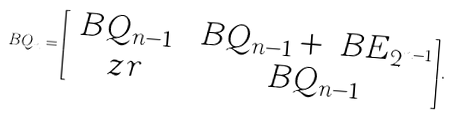<formula> <loc_0><loc_0><loc_500><loc_500>\ B Q _ { n } = \begin{bmatrix} \ B Q _ { n - 1 } & \ B Q _ { n - 1 } + \ B E _ { 2 ^ { n - 1 } } \\ \ z r & \ B Q _ { n - 1 } \end{bmatrix} .</formula> 